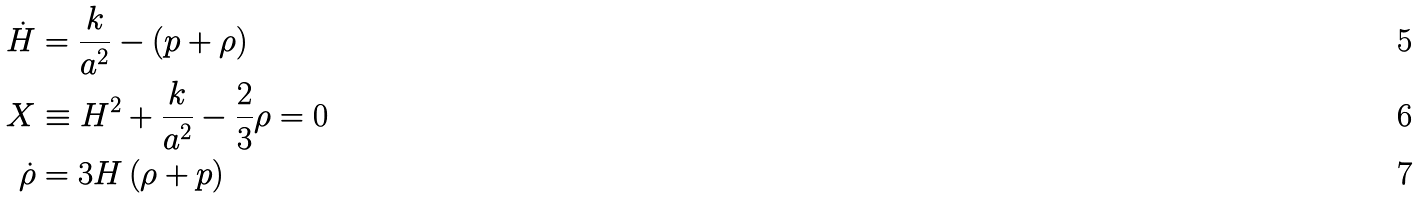<formula> <loc_0><loc_0><loc_500><loc_500>\dot { H } & = \frac { k } { a ^ { 2 } } - \left ( p + \rho \right ) \\ X & \equiv H ^ { 2 } + \frac { k } { a ^ { 2 } } - \frac { 2 } { 3 } \rho = 0 \\ \dot { \rho } & = 3 H \left ( \rho + p \right )</formula> 